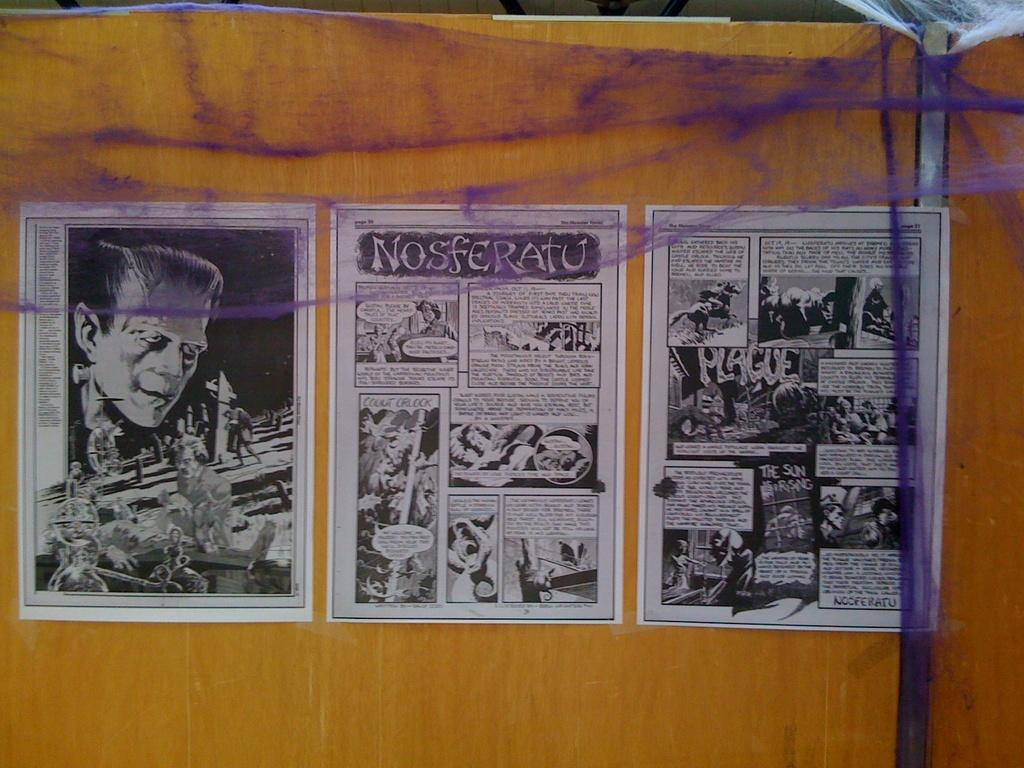<image>
Describe the image concisely. Comic strip of noseferatu on a paper on a brown board 